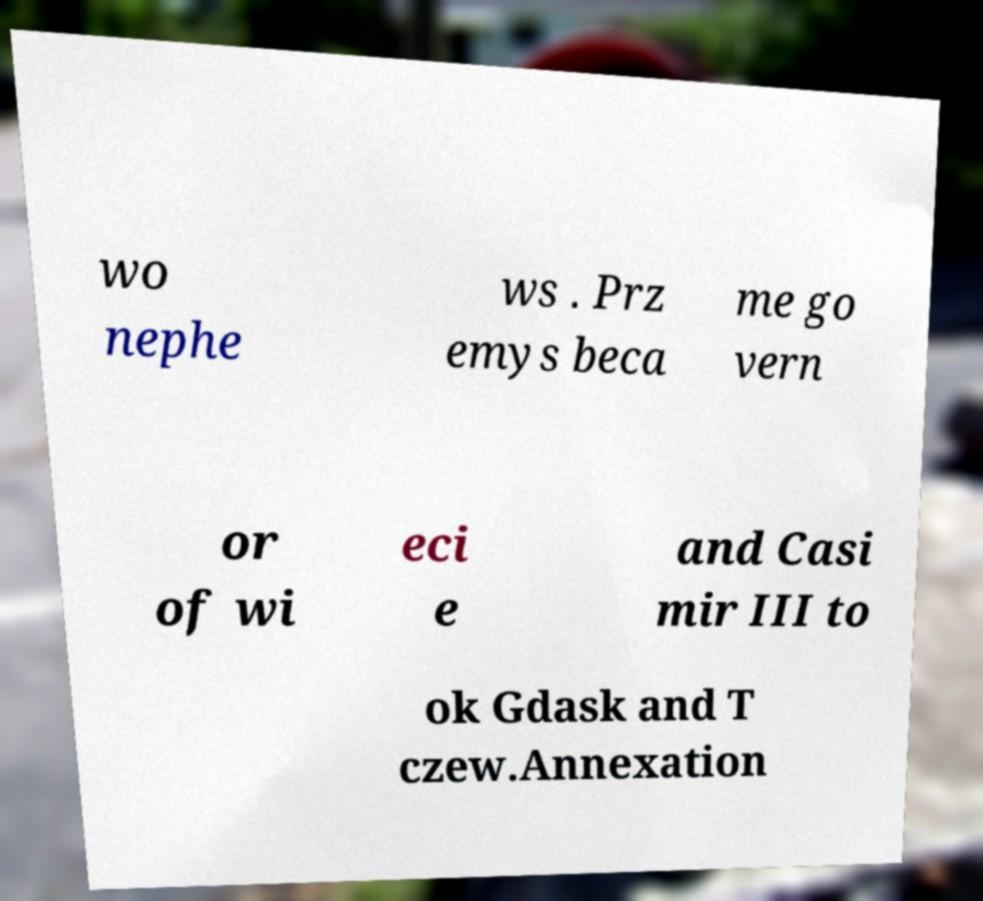There's text embedded in this image that I need extracted. Can you transcribe it verbatim? wo nephe ws . Prz emys beca me go vern or of wi eci e and Casi mir III to ok Gdask and T czew.Annexation 